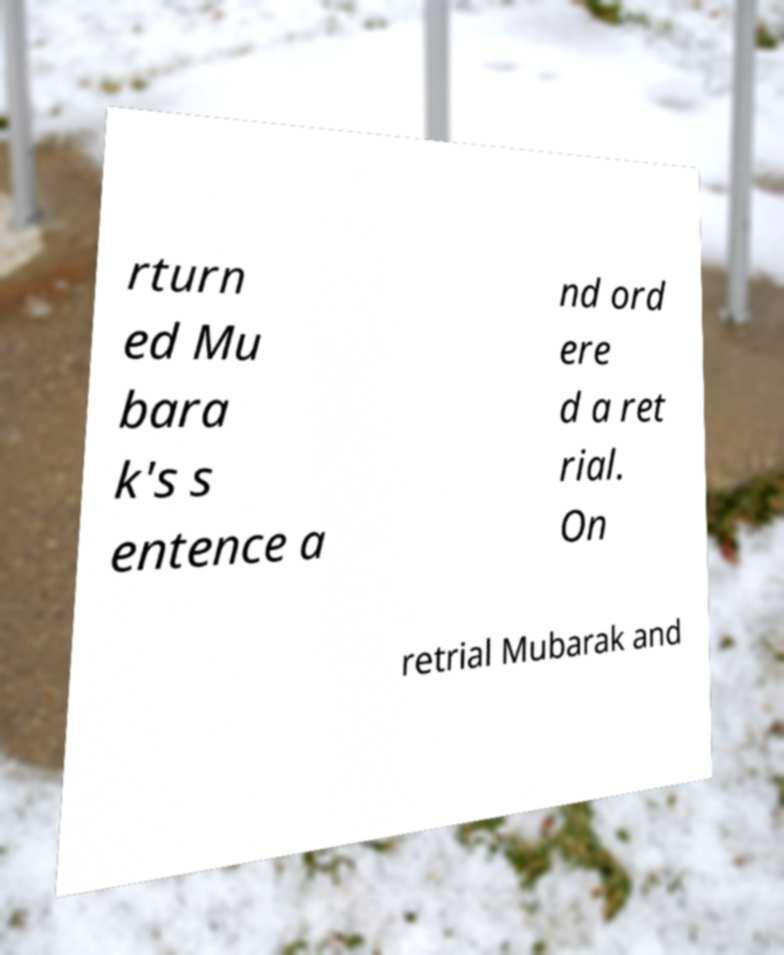Please read and relay the text visible in this image. What does it say? rturn ed Mu bara k's s entence a nd ord ere d a ret rial. On retrial Mubarak and 